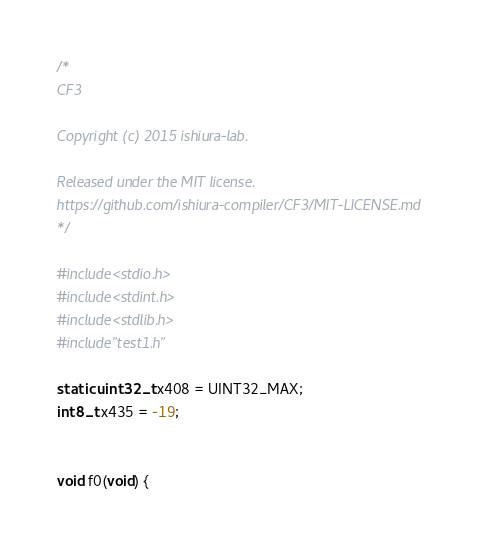Convert code to text. <code><loc_0><loc_0><loc_500><loc_500><_C_>
/*
CF3

Copyright (c) 2015 ishiura-lab.

Released under the MIT license.  
https://github.com/ishiura-compiler/CF3/MIT-LICENSE.md
*/

#include<stdio.h>
#include<stdint.h>
#include<stdlib.h>
#include"test1.h"

static uint32_t x408 = UINT32_MAX;
int8_t x435 = -19;


void f0(void) {</code> 